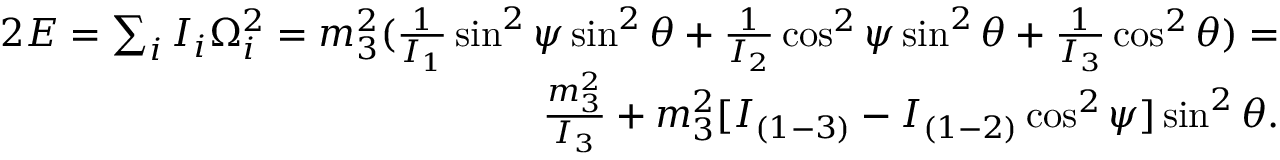Convert formula to latex. <formula><loc_0><loc_0><loc_500><loc_500>\begin{array} { r } { 2 E = \sum _ { i } I _ { i } \Omega _ { i } ^ { 2 } = m _ { 3 } ^ { 2 } ( \frac { 1 } { I _ { 1 } } \sin ^ { 2 } \psi \sin ^ { 2 } \theta + \frac { 1 } { I _ { 2 } } \cos ^ { 2 } \psi \sin ^ { 2 } \theta + \frac { 1 } { I _ { 3 } } \cos ^ { 2 } \theta ) = } \\ { \frac { m _ { 3 } ^ { 2 } } { I _ { 3 } } + m _ { 3 } ^ { 2 } [ I _ { ( 1 - 3 ) } - I _ { ( 1 - 2 ) } \cos ^ { 2 } \psi ] \sin ^ { 2 } \theta . } \end{array}</formula> 